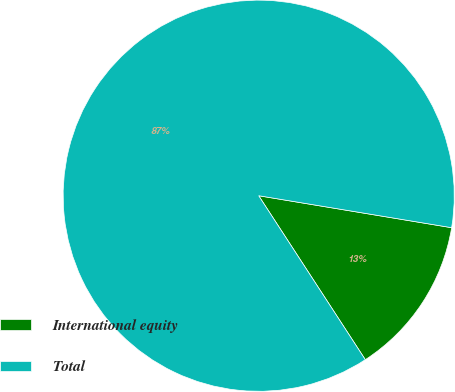Convert chart. <chart><loc_0><loc_0><loc_500><loc_500><pie_chart><fcel>International equity<fcel>Total<nl><fcel>13.21%<fcel>86.79%<nl></chart> 